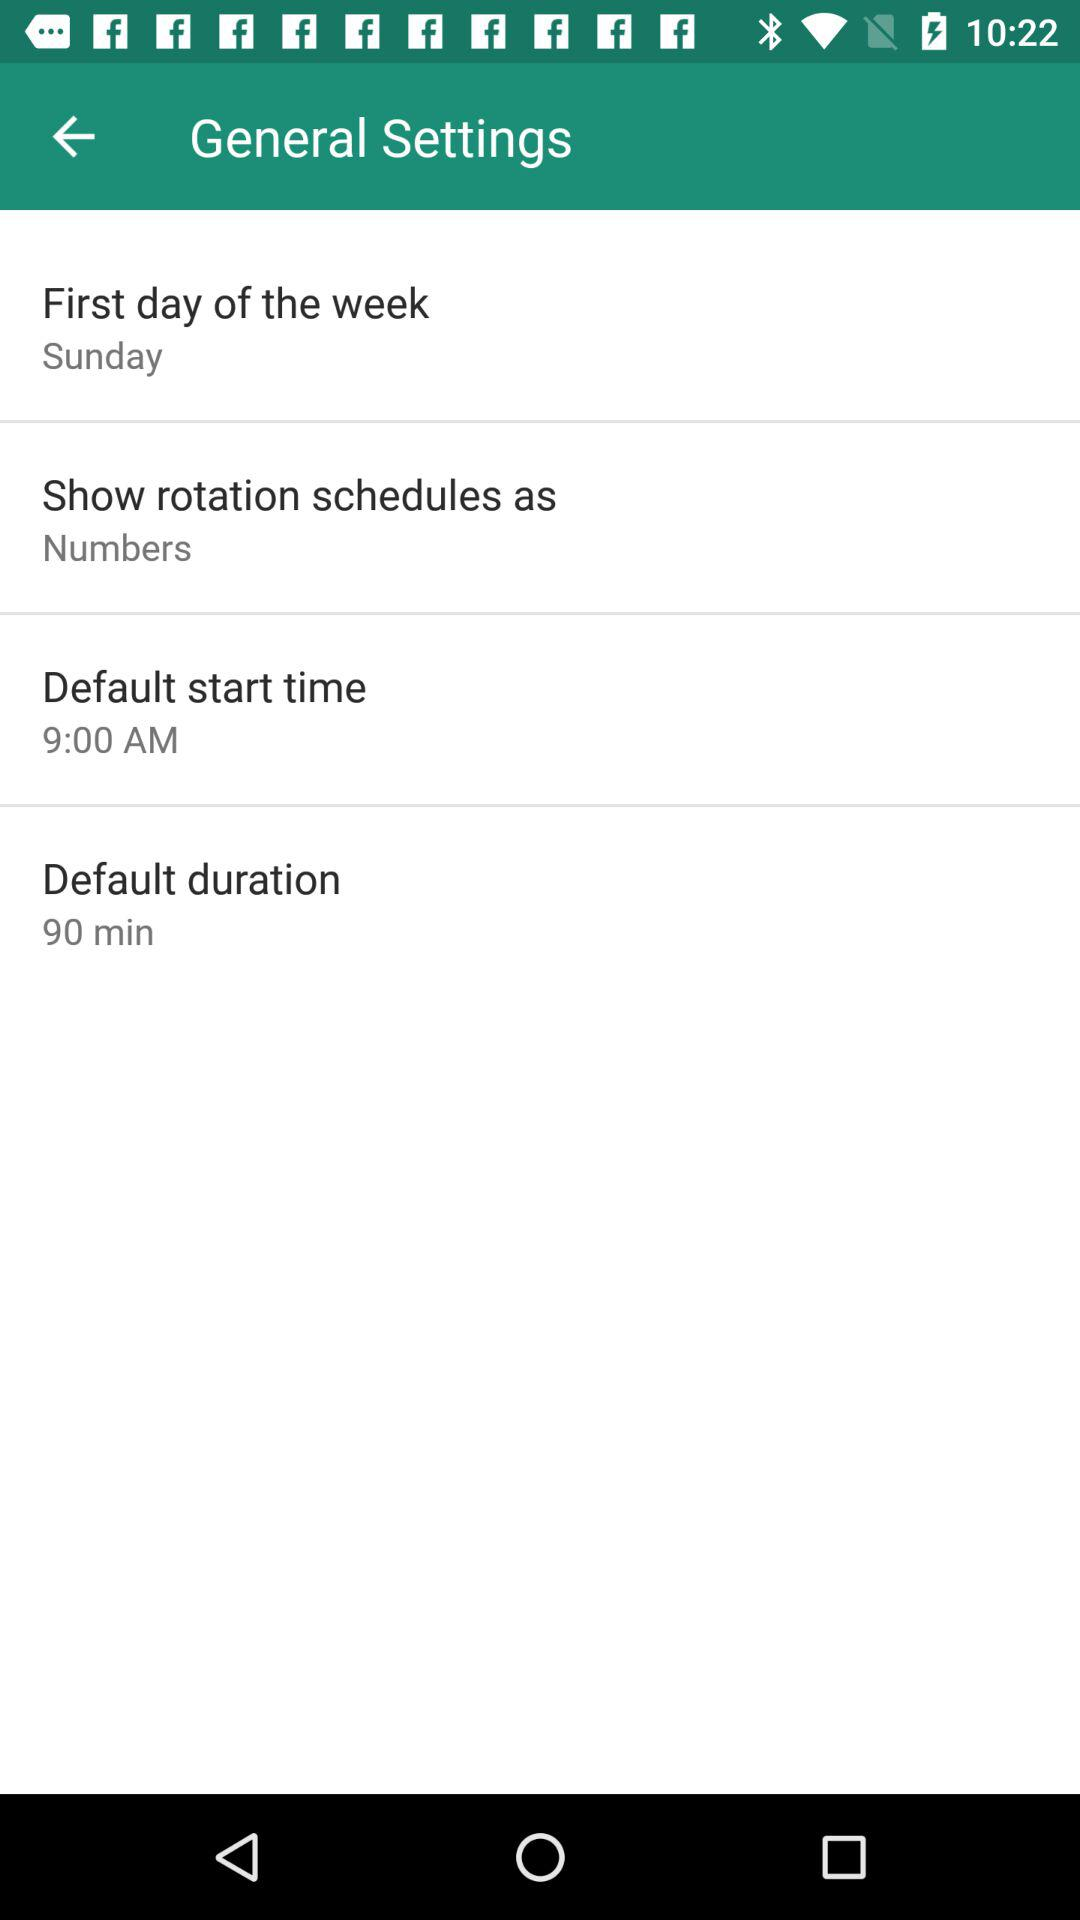What is the default duration? The default duration is 90 minutes. 